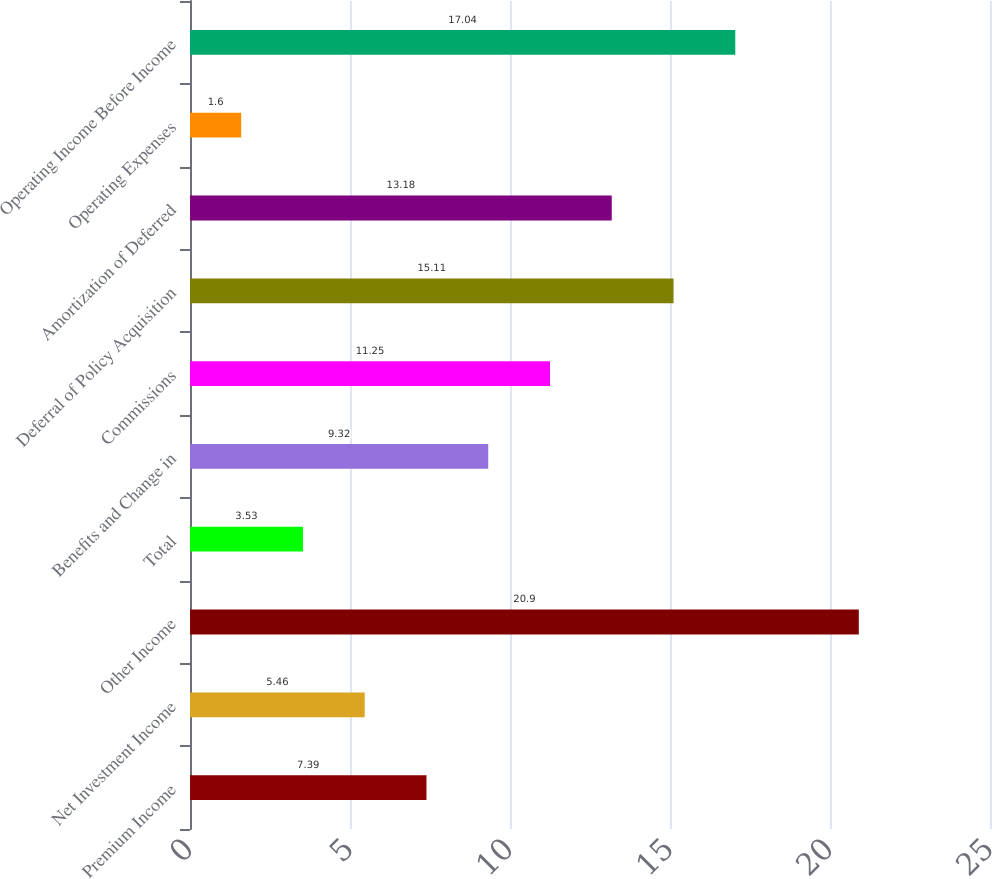Convert chart. <chart><loc_0><loc_0><loc_500><loc_500><bar_chart><fcel>Premium Income<fcel>Net Investment Income<fcel>Other Income<fcel>Total<fcel>Benefits and Change in<fcel>Commissions<fcel>Deferral of Policy Acquisition<fcel>Amortization of Deferred<fcel>Operating Expenses<fcel>Operating Income Before Income<nl><fcel>7.39<fcel>5.46<fcel>20.9<fcel>3.53<fcel>9.32<fcel>11.25<fcel>15.11<fcel>13.18<fcel>1.6<fcel>17.04<nl></chart> 